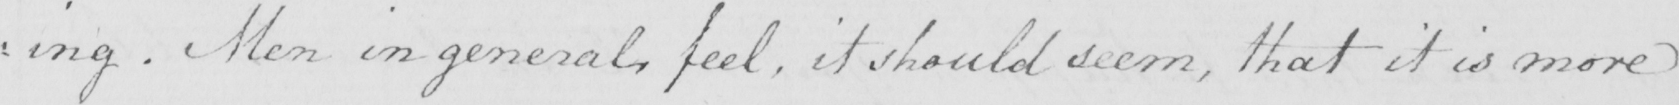Please provide the text content of this handwritten line. : ing . Men in general , feel , it should seem , that it is more 